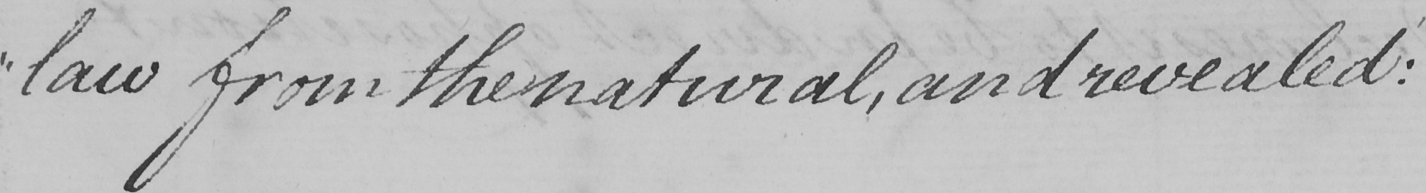Please provide the text content of this handwritten line. " law from the natural , and revealed : 